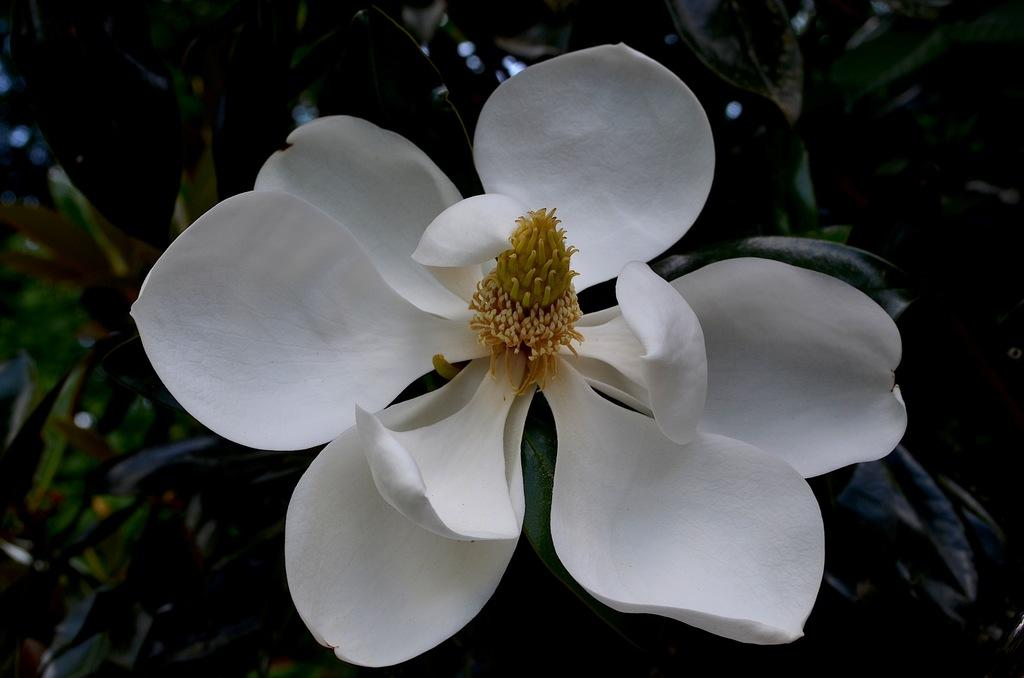What is the main subject of the image? The main subject of the image is a white flower. Can you describe any other elements in the image? Leaves are visible in the background of the image. Where is the pig located in the image? There is no pig present in the image; it features a close-up of a white flower and leaves in the background. What type of feather can be seen in the image? There are no feathers present in the image. 